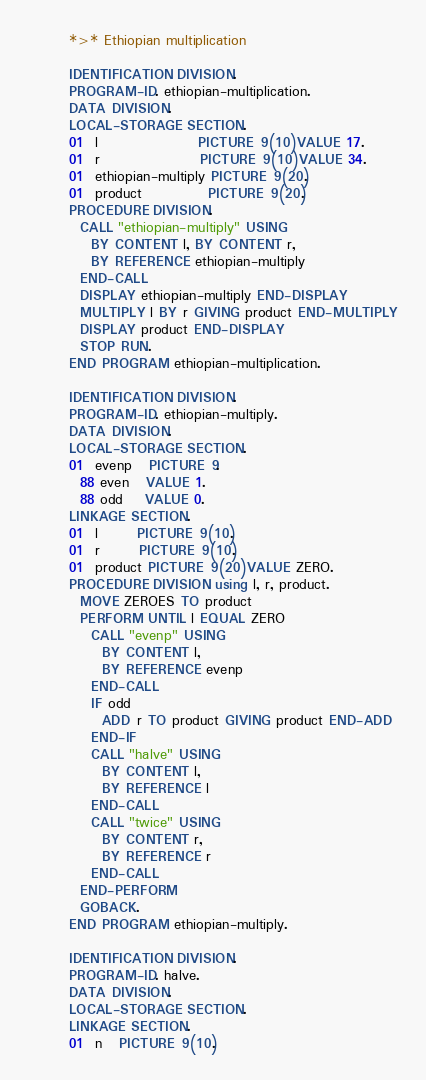<code> <loc_0><loc_0><loc_500><loc_500><_COBOL_>       *>* Ethiopian multiplication

       IDENTIFICATION DIVISION.
       PROGRAM-ID. ethiopian-multiplication.
       DATA DIVISION.
       LOCAL-STORAGE SECTION.
       01  l                  PICTURE 9(10) VALUE 17.
       01  r                  PICTURE 9(10) VALUE 34.
       01  ethiopian-multiply PICTURE 9(20).
       01  product            PICTURE 9(20).
       PROCEDURE DIVISION.
         CALL "ethiopian-multiply" USING
           BY CONTENT l, BY CONTENT r,
           BY REFERENCE ethiopian-multiply
         END-CALL
         DISPLAY ethiopian-multiply END-DISPLAY
         MULTIPLY l BY r GIVING product END-MULTIPLY
         DISPLAY product END-DISPLAY
         STOP RUN.
       END PROGRAM ethiopian-multiplication.

       IDENTIFICATION DIVISION.
       PROGRAM-ID. ethiopian-multiply.
       DATA DIVISION.
       LOCAL-STORAGE SECTION.
       01  evenp   PICTURE 9.
         88 even   VALUE 1.
         88 odd    VALUE 0.
       LINKAGE SECTION.
       01  l       PICTURE 9(10).
       01  r       PICTURE 9(10).
       01  product PICTURE 9(20) VALUE ZERO.
       PROCEDURE DIVISION using l, r, product.
         MOVE ZEROES TO product
         PERFORM UNTIL l EQUAL ZERO
           CALL "evenp" USING
             BY CONTENT l,
             BY REFERENCE evenp
           END-CALL
           IF odd
             ADD r TO product GIVING product END-ADD
           END-IF
           CALL "halve" USING
             BY CONTENT l,
             BY REFERENCE l
           END-CALL
           CALL "twice" USING
             BY CONTENT r,
             BY REFERENCE r
           END-CALL
         END-PERFORM
         GOBACK.
       END PROGRAM ethiopian-multiply.

       IDENTIFICATION DIVISION.
       PROGRAM-ID. halve.
       DATA DIVISION.
       LOCAL-STORAGE SECTION.
       LINKAGE SECTION.
       01  n   PICTURE 9(10).</code> 